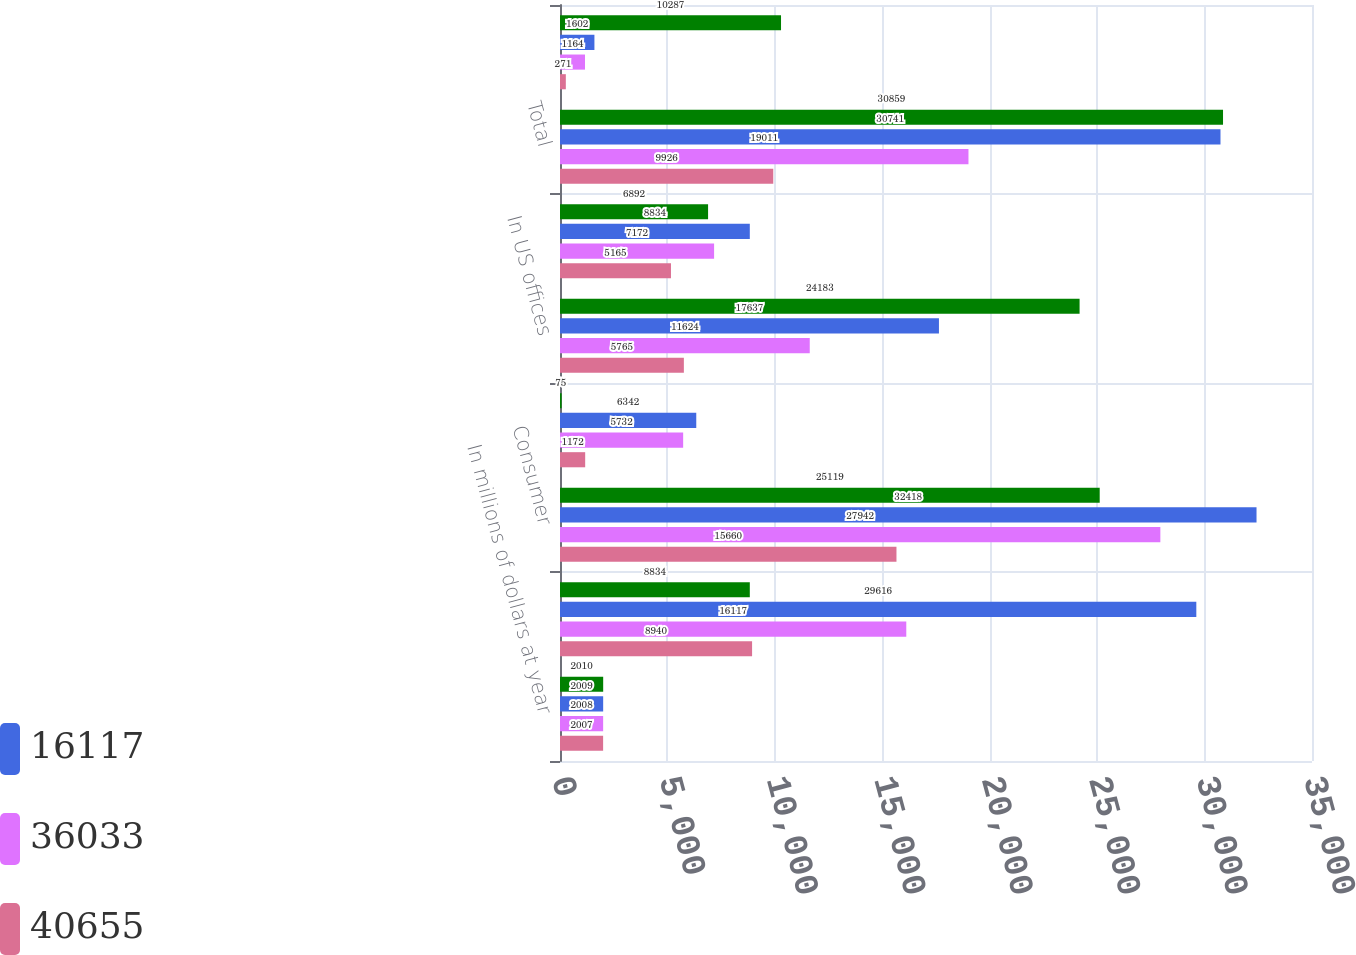<chart> <loc_0><loc_0><loc_500><loc_500><stacked_bar_chart><ecel><fcel>In millions of dollars at year<fcel>Allowance for loan losses at<fcel>Consumer<fcel>Corporate<fcel>In US offices<fcel>In offices outside the US<fcel>Total<fcel>Other-net (1)<nl><fcel>nan<fcel>2010<fcel>8834<fcel>25119<fcel>75<fcel>24183<fcel>6892<fcel>30859<fcel>10287<nl><fcel>16117<fcel>2009<fcel>29616<fcel>32418<fcel>6342<fcel>17637<fcel>8834<fcel>30741<fcel>1602<nl><fcel>36033<fcel>2008<fcel>16117<fcel>27942<fcel>5732<fcel>11624<fcel>7172<fcel>19011<fcel>1164<nl><fcel>40655<fcel>2007<fcel>8940<fcel>15660<fcel>1172<fcel>5765<fcel>5165<fcel>9926<fcel>271<nl></chart> 